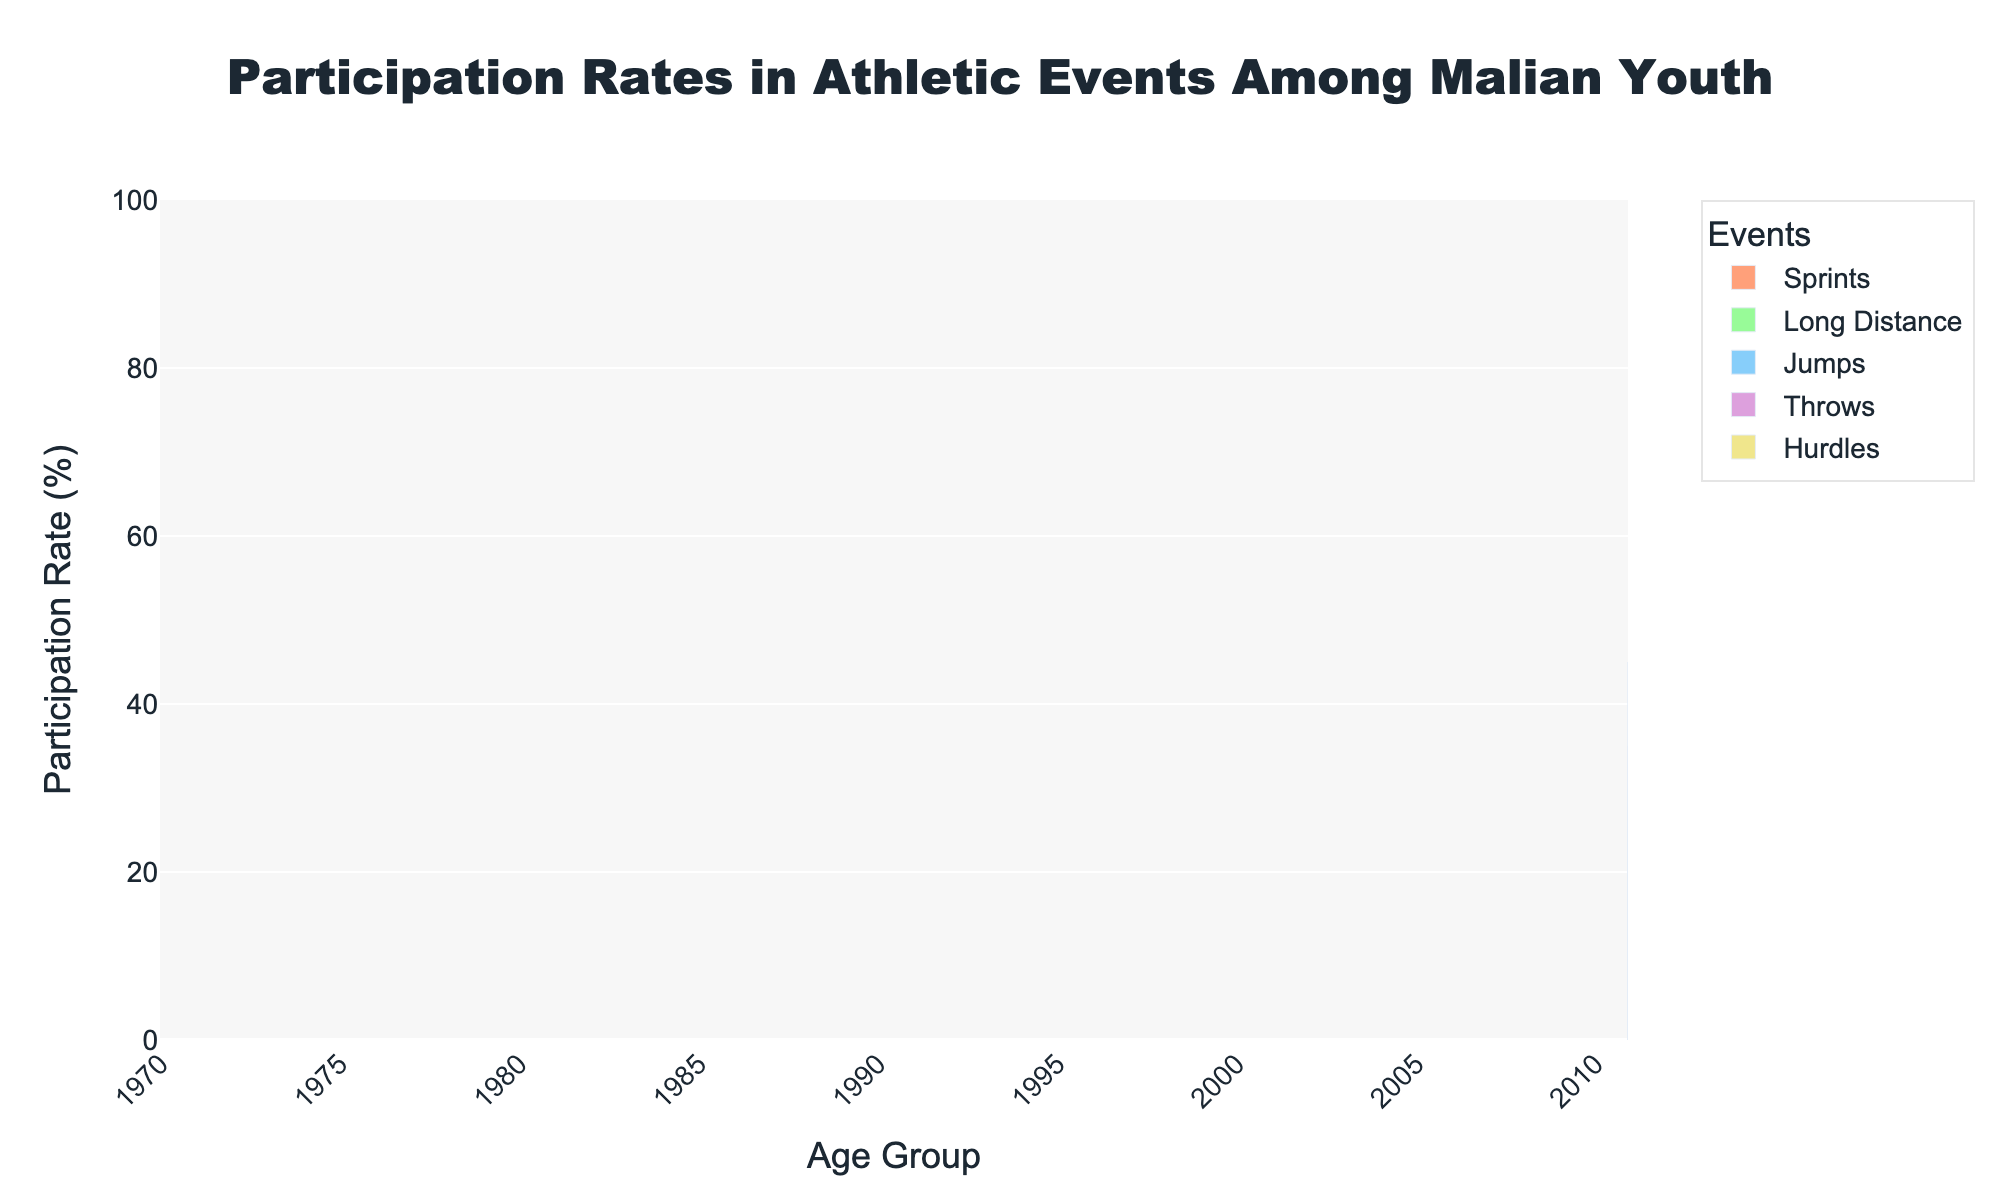What is the most popular event for the age group 10-12? Look at the height of the bars for the age group 10-12 and identify which bar is the tallest. The tallest bar represents the most popular event.
Answer: Sprints Which age group participates the most in throws? Observe the height of the bars for the "Throws" event across all age groups and identify which one is the tallest.
Answer: 25-29 Between the age groups 16-18 and 19-21, which event shows the highest increase in participation? Compare the participation rates for each event (Sprints, Long Distance, Jumps, Throws, Hurdles) between the age groups 16-18 and 19-21. Calculate the difference for each event and identify the event with the highest positive difference.
Answer: Long Distance Which event has the lowest participation rate for the age group 13-15? For the age group 13-15, compare the height of all the bars and identify which bar is the shortest.
Answer: Hurdles Between the age groups 22-24 and 25-29, does participation in sprints increase or decrease? Compare the height of the "Sprints" bar for the age group 22-24 with the height of the "Sprints" bar for the age group 25-29. Determine whether the height has increased or decreased.
Answer: Decrease What is the total participation rate for the Jumps event across all age groups? Sum up the heights of the bars for the "Jumps" event across all age groups (35 + 45 + 55 + 60 + 50 + 45).
Answer: 290 How does the participation in hurdles change from age group 10-12 to 25-29? Note the height of the "Hurdles" bars for each relevant age group and observe the pattern: 10-12 (20), 13-15 (30), 16-18 (40), 19-21 (45), 22-24 (40), and 25-29 (35). Describe this pattern.
Answer: Increases and then decreases For the age group 22-24, which event has higher participation: Long Distance or Throws? Compare the heights of the bars for "Long Distance" and "Throws" for the age group 22-24; identify which bar is taller.
Answer: Long Distance What is the average participation rate for all events in the age group 19-21? Sum the participation rates for all events in the age group 19-21 (70 + 60 + 60 + 50 + 45) and divide by the number of events (5).
Answer: 57 Across all age groups, which event has the highest participation rate? Identify the tallest bar in each age group and determine which event it represents. Then, compare these maximum values to identify the event that occurs most frequently as the tallest.
Answer: Sprints 